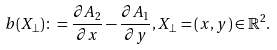Convert formula to latex. <formula><loc_0><loc_0><loc_500><loc_500>b ( X _ { \perp } ) \colon = \frac { \partial A _ { 2 } } { \partial x } - \frac { \partial A _ { 1 } } { \partial y } , X _ { \perp } = ( x , y ) \in \mathbb { R } ^ { 2 } .</formula> 